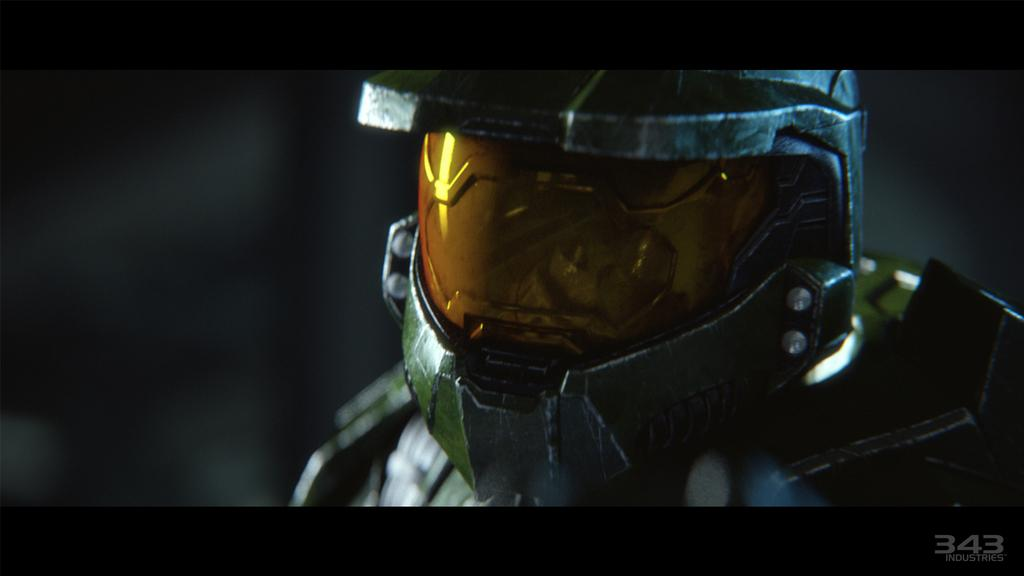What type of headgear is visible in the image? There is a metal helmet in the image. What is the metal helmet placed on? The metal helmet is on an armored suited structure. What type of owl can be seen sitting on the metal helmet in the image? There is no owl present in the image; it only features a metal helmet on an armored suited structure. 